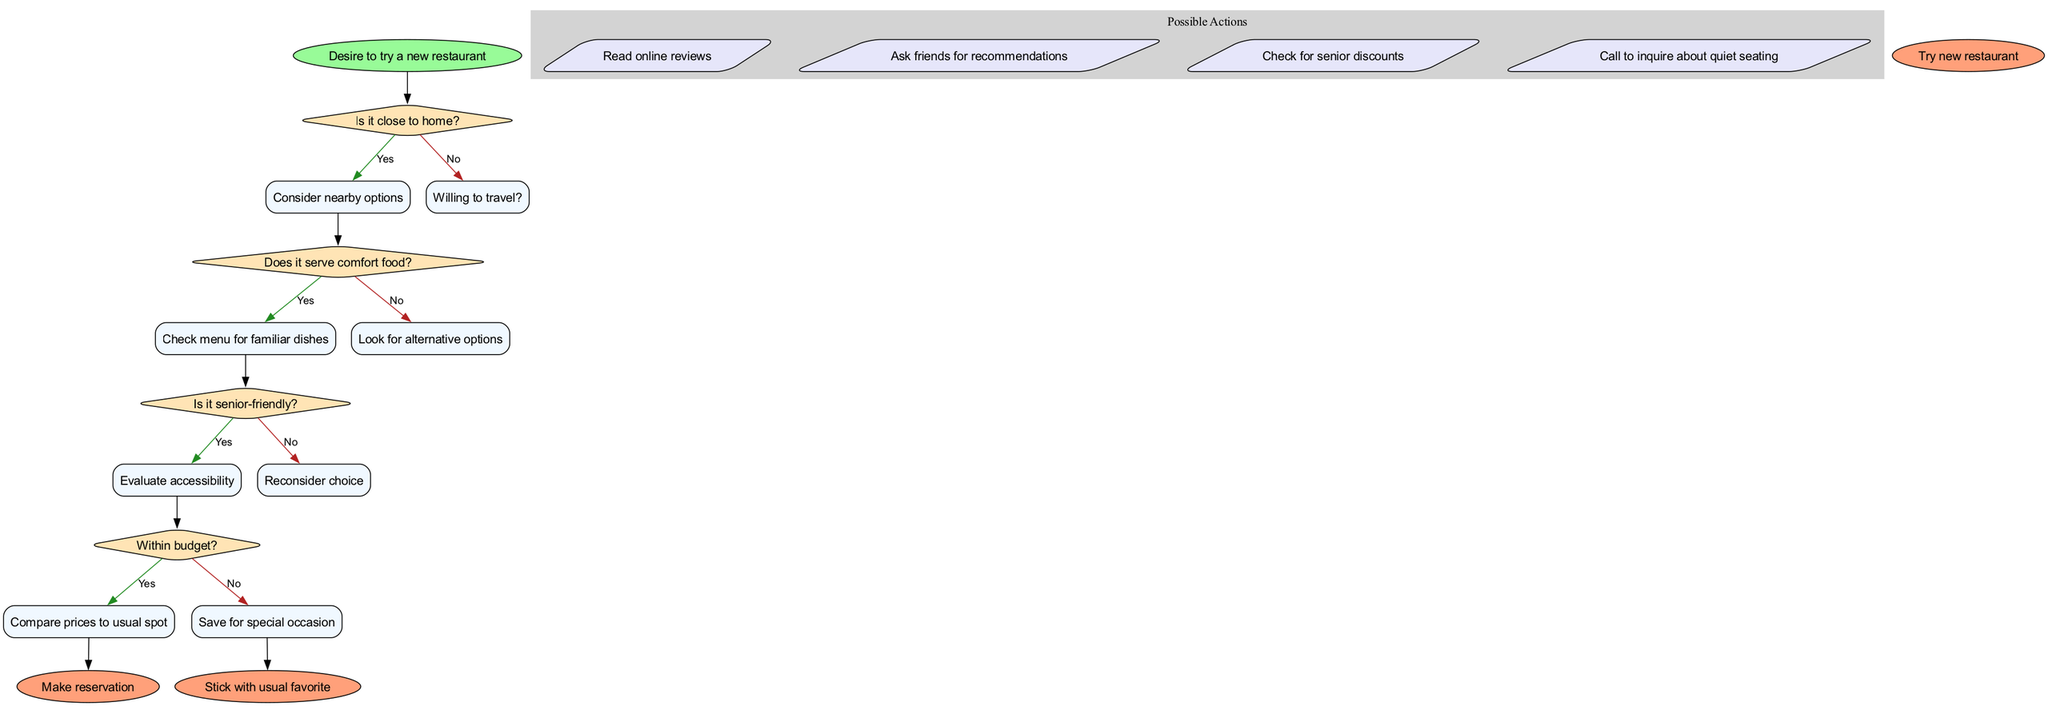What is the starting point of the flow chart? The flow chart begins with the node labeled "Desire to try a new restaurant". This is indicated by the 'start' node, which is connected to the first decision node regarding proximity to home.
Answer: Desire to try a new restaurant How many decision nodes are there in the flow chart? There are four decision nodes represented in the flow chart. Each decision node addresses a specific question about choosing a new restaurant.
Answer: 4 What does the first decision node ask? The first decision node in the flow chart asks, "Is it close to home?". This question determines the next steps in the decision-making process.
Answer: Is it close to home? If the answer to the last decision is no, what happens next? If the answer to the last decision about being within budget is no, the flow chart directs to "Save for special occasion", indicating that the choice of the restaurant is not budget-friendly.
Answer: Save for special occasion What action follows after confirming that the restaurant is senior-friendly? After confirming that the restaurant is senior-friendly, the flow chart suggests to "Evaluate accessibility". This is a logical step to ensure that the restaurant meets the needs of senior diners.
Answer: Evaluate accessibility What is the final outcome if all decisions lead to 'yes'? If all decisions lead to 'yes', the final outcome of the flow chart is "Try new restaurant". This indicates that all criteria have been met for selecting a new restaurant.
Answer: Try new restaurant Which action follows after checking for comfort food? After checking if the new restaurant serves comfort food, the next action suggested is to "Check menu for familiar dishes". This ensures familiarity with the food being served.
Answer: Check menu for familiar dishes How many possible actions are listed in the flow chart? There are four possible actions indicated within the action cluster of the flow chart. Each action provides a way to gather more information or recommendations about the restaurant.
Answer: 4 